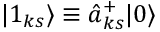Convert formula to latex. <formula><loc_0><loc_0><loc_500><loc_500>| 1 _ { k s } \rangle \equiv \hat { a } _ { k s } ^ { + } | 0 \rangle</formula> 